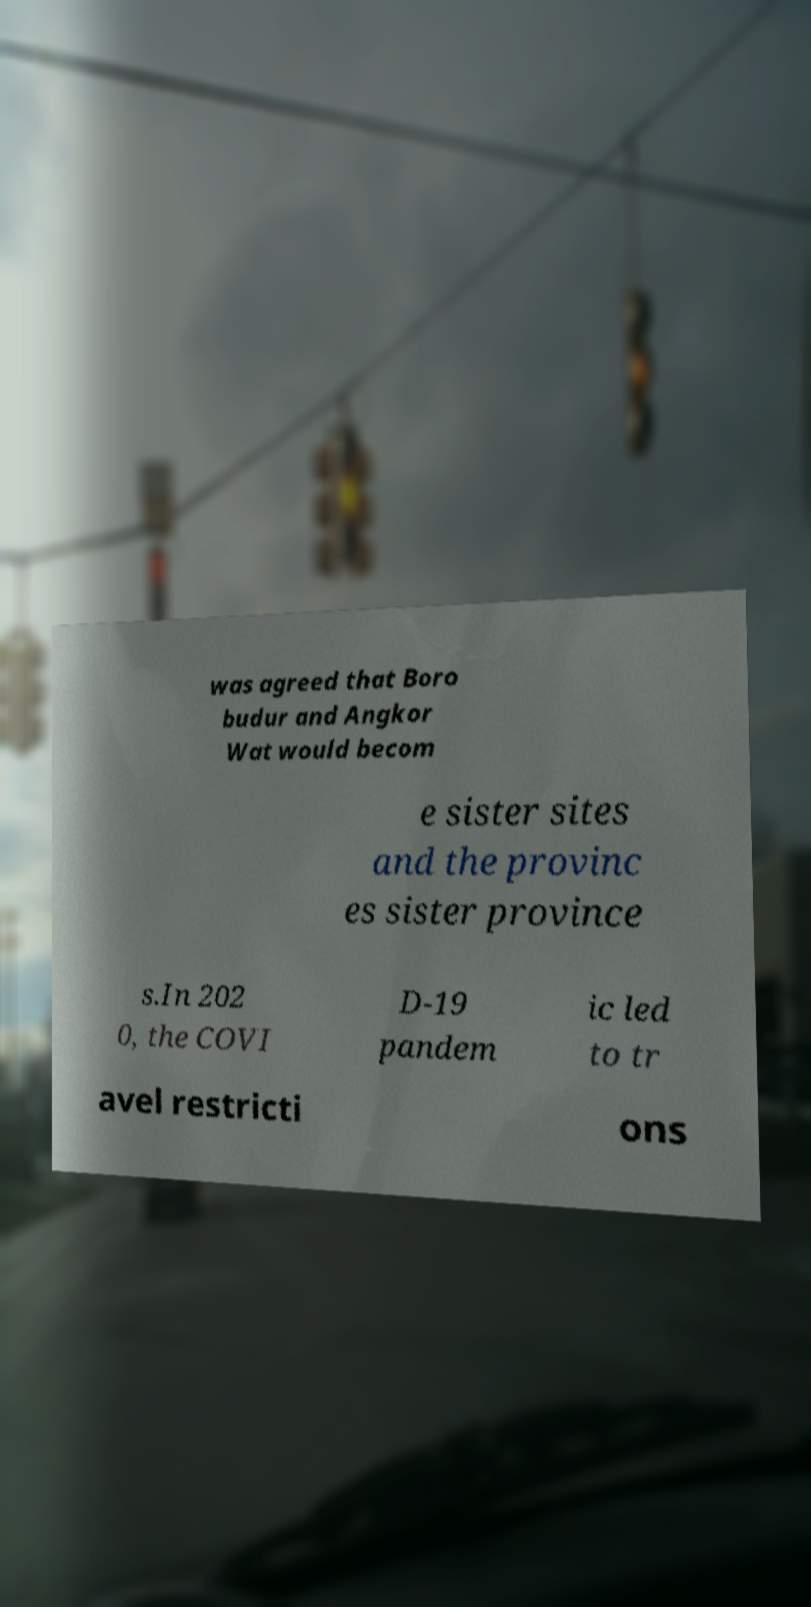Can you read and provide the text displayed in the image?This photo seems to have some interesting text. Can you extract and type it out for me? was agreed that Boro budur and Angkor Wat would becom e sister sites and the provinc es sister province s.In 202 0, the COVI D-19 pandem ic led to tr avel restricti ons 